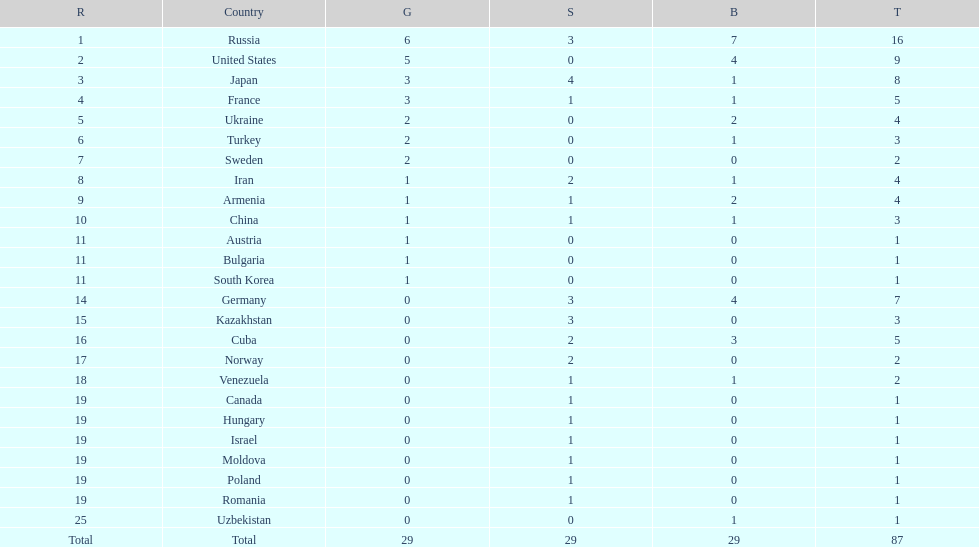Which country had the highest number of medals? Russia. 